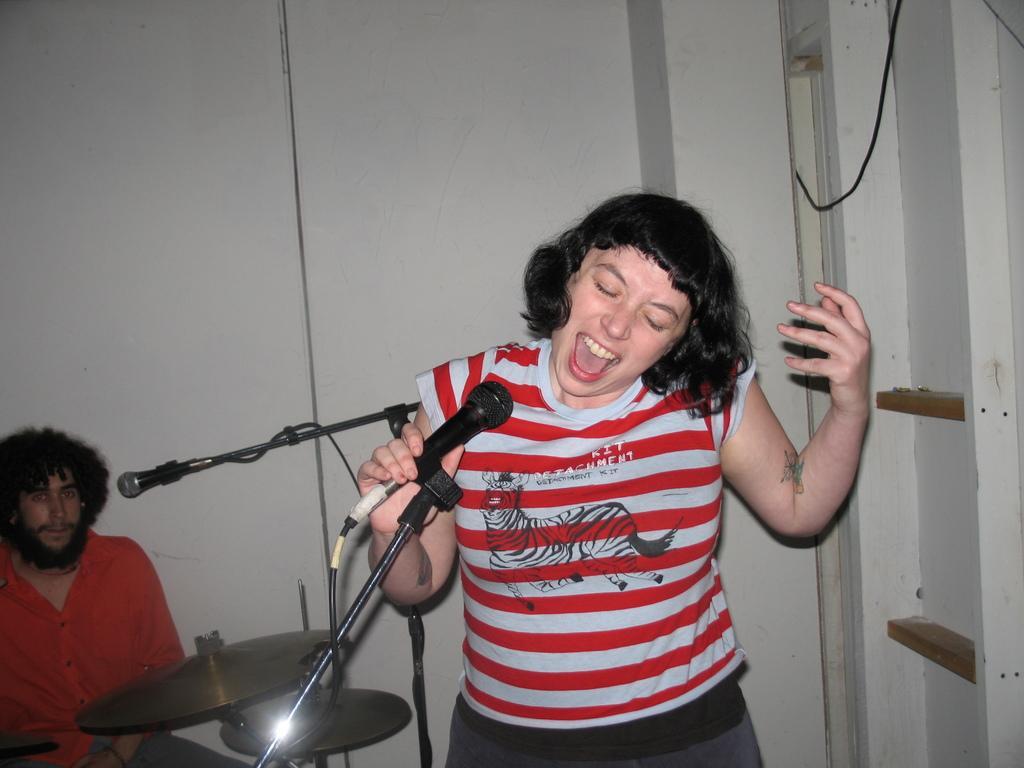Please provide a concise description of this image. In the image we can see there is a person who is standing in front of her and there is a mic and at the back there is a man who is sitting and playing a drum set. 